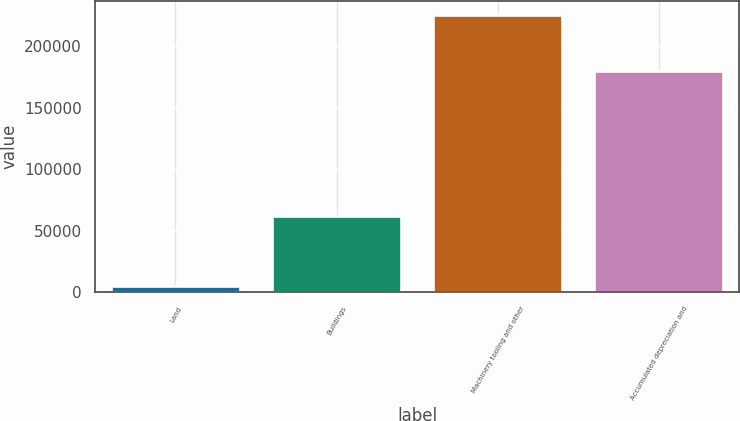Convert chart. <chart><loc_0><loc_0><loc_500><loc_500><bar_chart><fcel>Land<fcel>Buildings<fcel>Machinery tooling and other<fcel>Accumulated depreciation and<nl><fcel>4738<fcel>61884<fcel>225632<fcel>179791<nl></chart> 